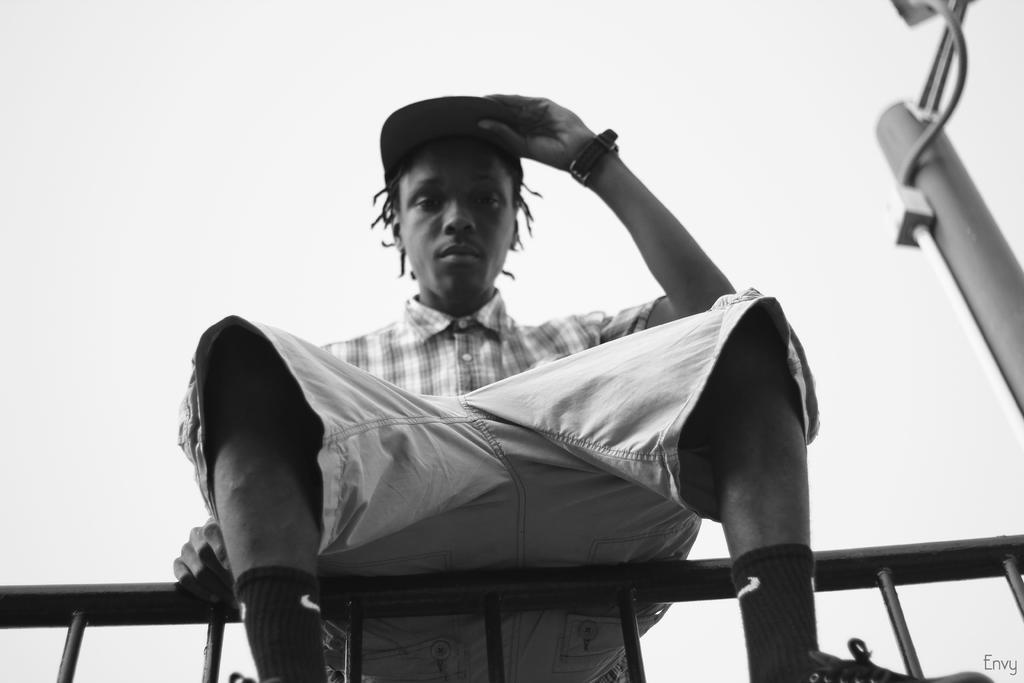Describe this image in one or two sentences. In this image there is a person sitting on the metal fence, behind the person there is a pole. 